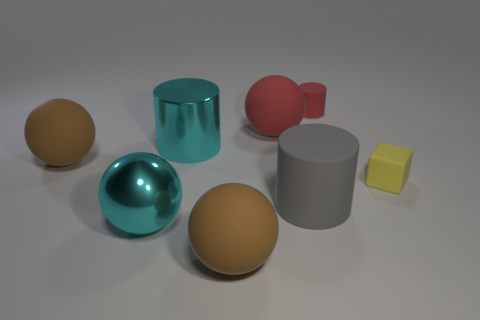What shape is the tiny red matte thing?
Keep it short and to the point. Cylinder. What is the big thing in front of the big shiny ball made of?
Offer a very short reply. Rubber. How many matte objects are either large gray things or big cyan cylinders?
Give a very brief answer. 1. Is there a yellow cube that has the same size as the cyan cylinder?
Ensure brevity in your answer.  No. Are there more red matte things that are behind the tiny red object than metal cylinders?
Your response must be concise. No. What number of tiny things are either gray rubber cylinders or metal blocks?
Make the answer very short. 0. How many big gray objects are the same shape as the small red rubber thing?
Your answer should be very brief. 1. There is a large brown sphere to the left of the big rubber sphere in front of the cube; what is it made of?
Your response must be concise. Rubber. There is a rubber object that is to the left of the large metal cylinder; what size is it?
Give a very brief answer. Large. How many brown objects are either balls or tiny rubber balls?
Your answer should be very brief. 2. 